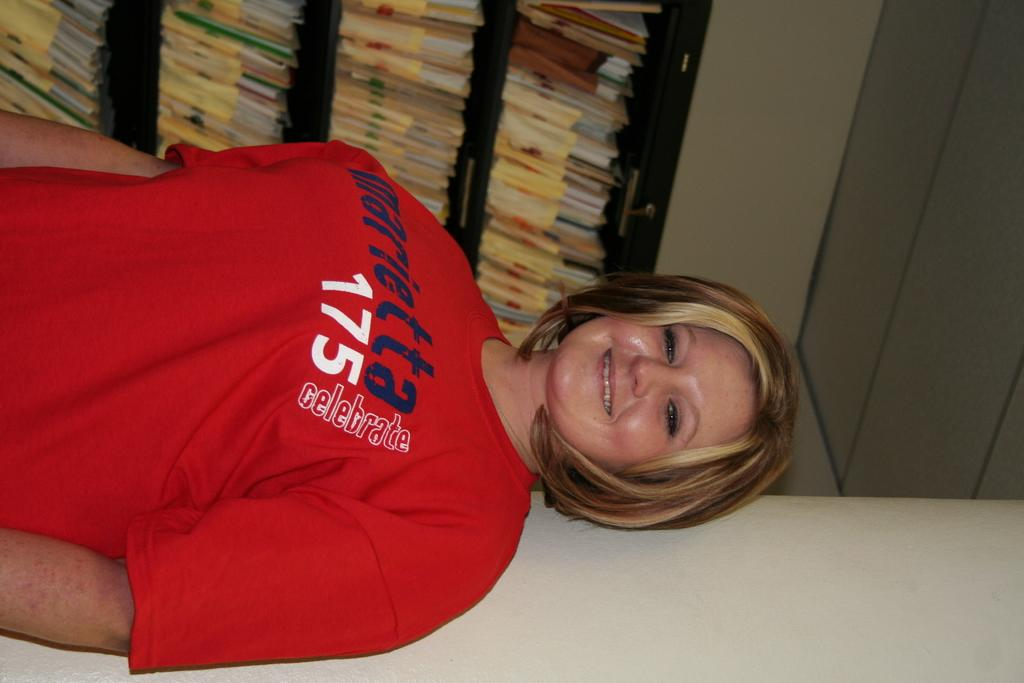<image>
Render a clear and concise summary of the photo. girl with a red shirt with the number 175 